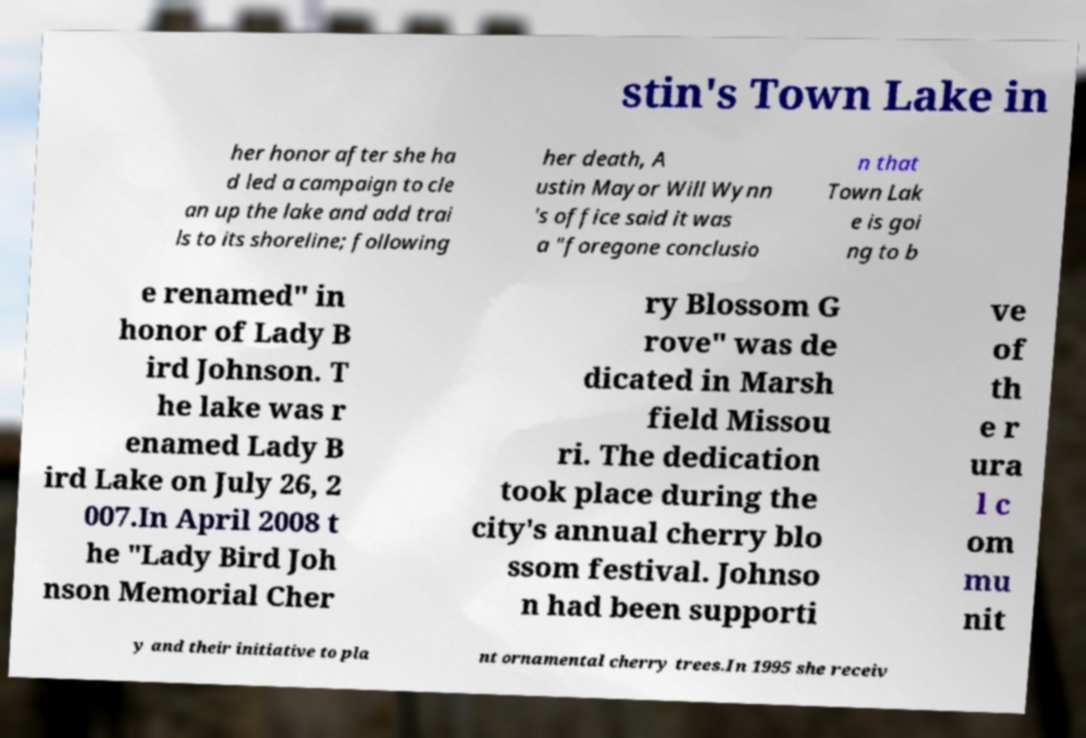Please identify and transcribe the text found in this image. stin's Town Lake in her honor after she ha d led a campaign to cle an up the lake and add trai ls to its shoreline; following her death, A ustin Mayor Will Wynn 's office said it was a "foregone conclusio n that Town Lak e is goi ng to b e renamed" in honor of Lady B ird Johnson. T he lake was r enamed Lady B ird Lake on July 26, 2 007.In April 2008 t he "Lady Bird Joh nson Memorial Cher ry Blossom G rove" was de dicated in Marsh field Missou ri. The dedication took place during the city's annual cherry blo ssom festival. Johnso n had been supporti ve of th e r ura l c om mu nit y and their initiative to pla nt ornamental cherry trees.In 1995 she receiv 